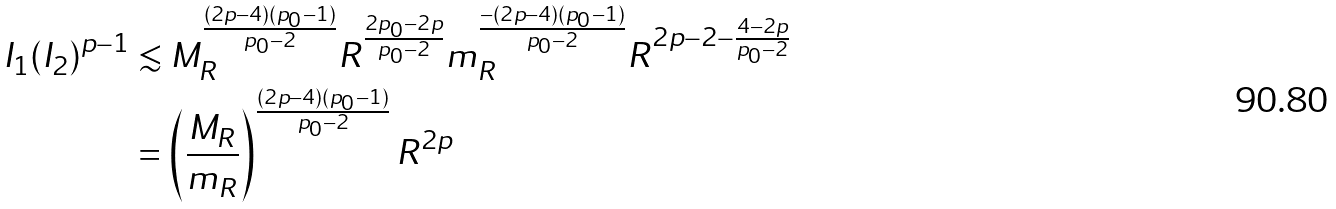<formula> <loc_0><loc_0><loc_500><loc_500>I _ { 1 } ( I _ { 2 } ) ^ { p - 1 } & \lesssim M _ { R } ^ { \frac { ( 2 p - 4 ) ( p _ { 0 } - 1 ) } { p _ { 0 } - 2 } } R ^ { \frac { 2 p _ { 0 } - 2 p } { p _ { 0 } - 2 } } m _ { R } ^ { \frac { - ( 2 p - 4 ) ( p _ { 0 } - 1 ) } { p _ { 0 } - 2 } } R ^ { 2 p - 2 - \frac { 4 - 2 p } { p _ { 0 } - 2 } } \\ & = \left ( \frac { M _ { R } } { m _ { R } } \right ) ^ { \frac { ( 2 p - 4 ) ( p _ { 0 } - 1 ) } { p _ { 0 } - 2 } } R ^ { 2 p }</formula> 